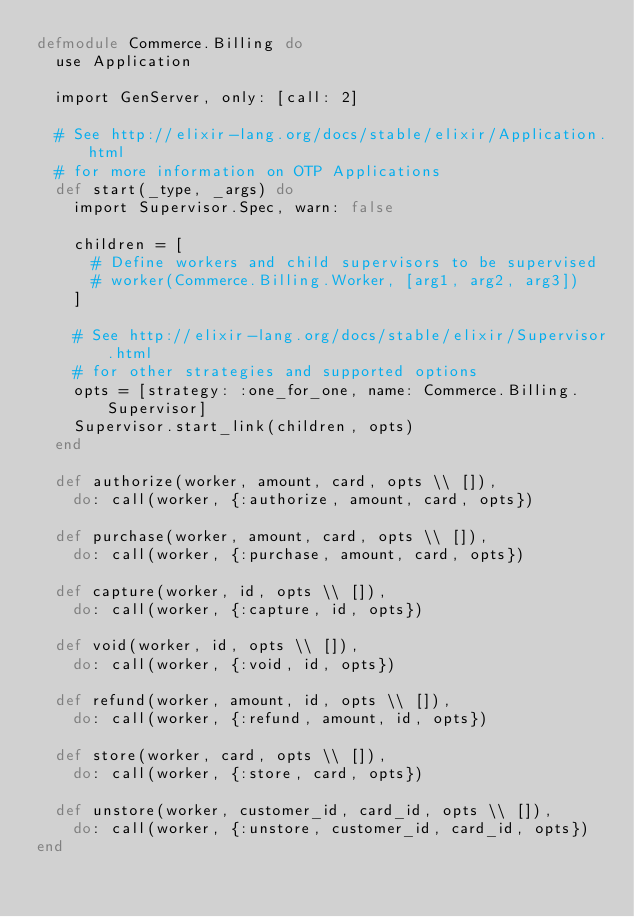<code> <loc_0><loc_0><loc_500><loc_500><_Elixir_>defmodule Commerce.Billing do
  use Application

  import GenServer, only: [call: 2]

  # See http://elixir-lang.org/docs/stable/elixir/Application.html
  # for more information on OTP Applications
  def start(_type, _args) do
    import Supervisor.Spec, warn: false

    children = [
      # Define workers and child supervisors to be supervised
      # worker(Commerce.Billing.Worker, [arg1, arg2, arg3])
    ]

    # See http://elixir-lang.org/docs/stable/elixir/Supervisor.html
    # for other strategies and supported options
    opts = [strategy: :one_for_one, name: Commerce.Billing.Supervisor]
    Supervisor.start_link(children, opts)
  end

  def authorize(worker, amount, card, opts \\ []),
    do: call(worker, {:authorize, amount, card, opts})

  def purchase(worker, amount, card, opts \\ []),
    do: call(worker, {:purchase, amount, card, opts})

  def capture(worker, id, opts \\ []),
    do: call(worker, {:capture, id, opts})

  def void(worker, id, opts \\ []),
    do: call(worker, {:void, id, opts})

  def refund(worker, amount, id, opts \\ []),
    do: call(worker, {:refund, amount, id, opts})

  def store(worker, card, opts \\ []),
    do: call(worker, {:store, card, opts})

  def unstore(worker, customer_id, card_id, opts \\ []),
    do: call(worker, {:unstore, customer_id, card_id, opts})
end
</code> 